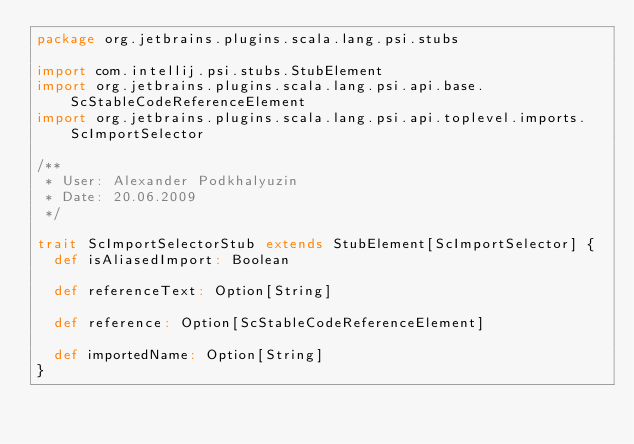Convert code to text. <code><loc_0><loc_0><loc_500><loc_500><_Scala_>package org.jetbrains.plugins.scala.lang.psi.stubs

import com.intellij.psi.stubs.StubElement
import org.jetbrains.plugins.scala.lang.psi.api.base.ScStableCodeReferenceElement
import org.jetbrains.plugins.scala.lang.psi.api.toplevel.imports.ScImportSelector

/**
 * User: Alexander Podkhalyuzin
 * Date: 20.06.2009
 */

trait ScImportSelectorStub extends StubElement[ScImportSelector] {
  def isAliasedImport: Boolean

  def referenceText: Option[String]

  def reference: Option[ScStableCodeReferenceElement]

  def importedName: Option[String]
}</code> 